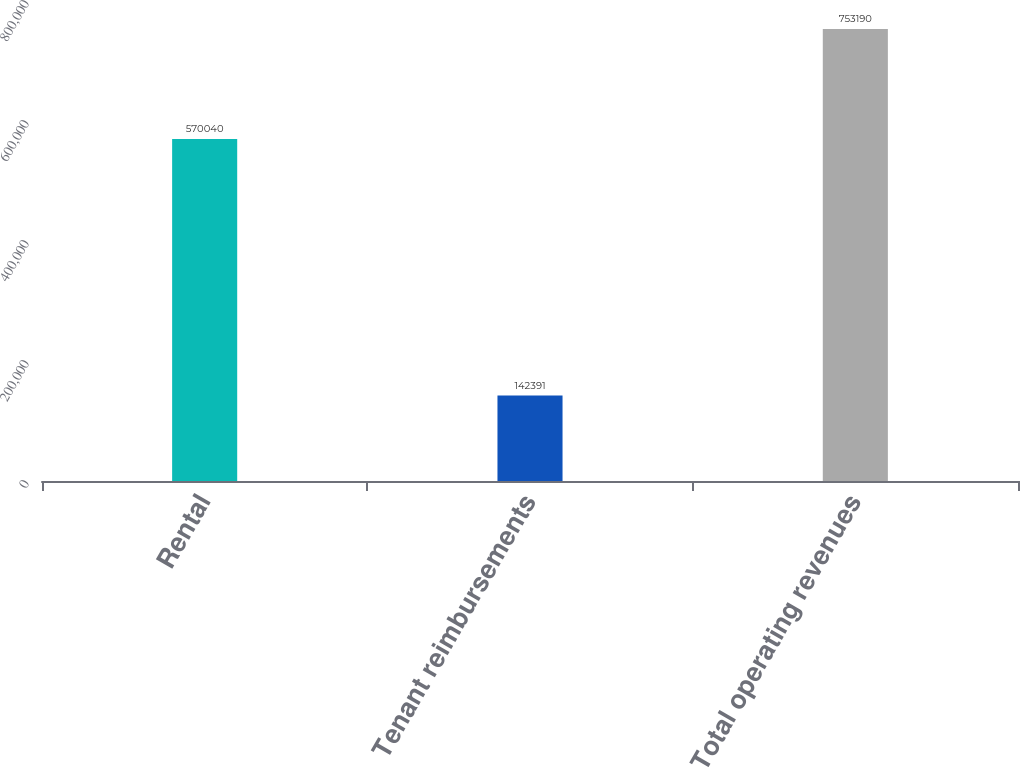Convert chart to OTSL. <chart><loc_0><loc_0><loc_500><loc_500><bar_chart><fcel>Rental<fcel>Tenant reimbursements<fcel>Total operating revenues<nl><fcel>570040<fcel>142391<fcel>753190<nl></chart> 